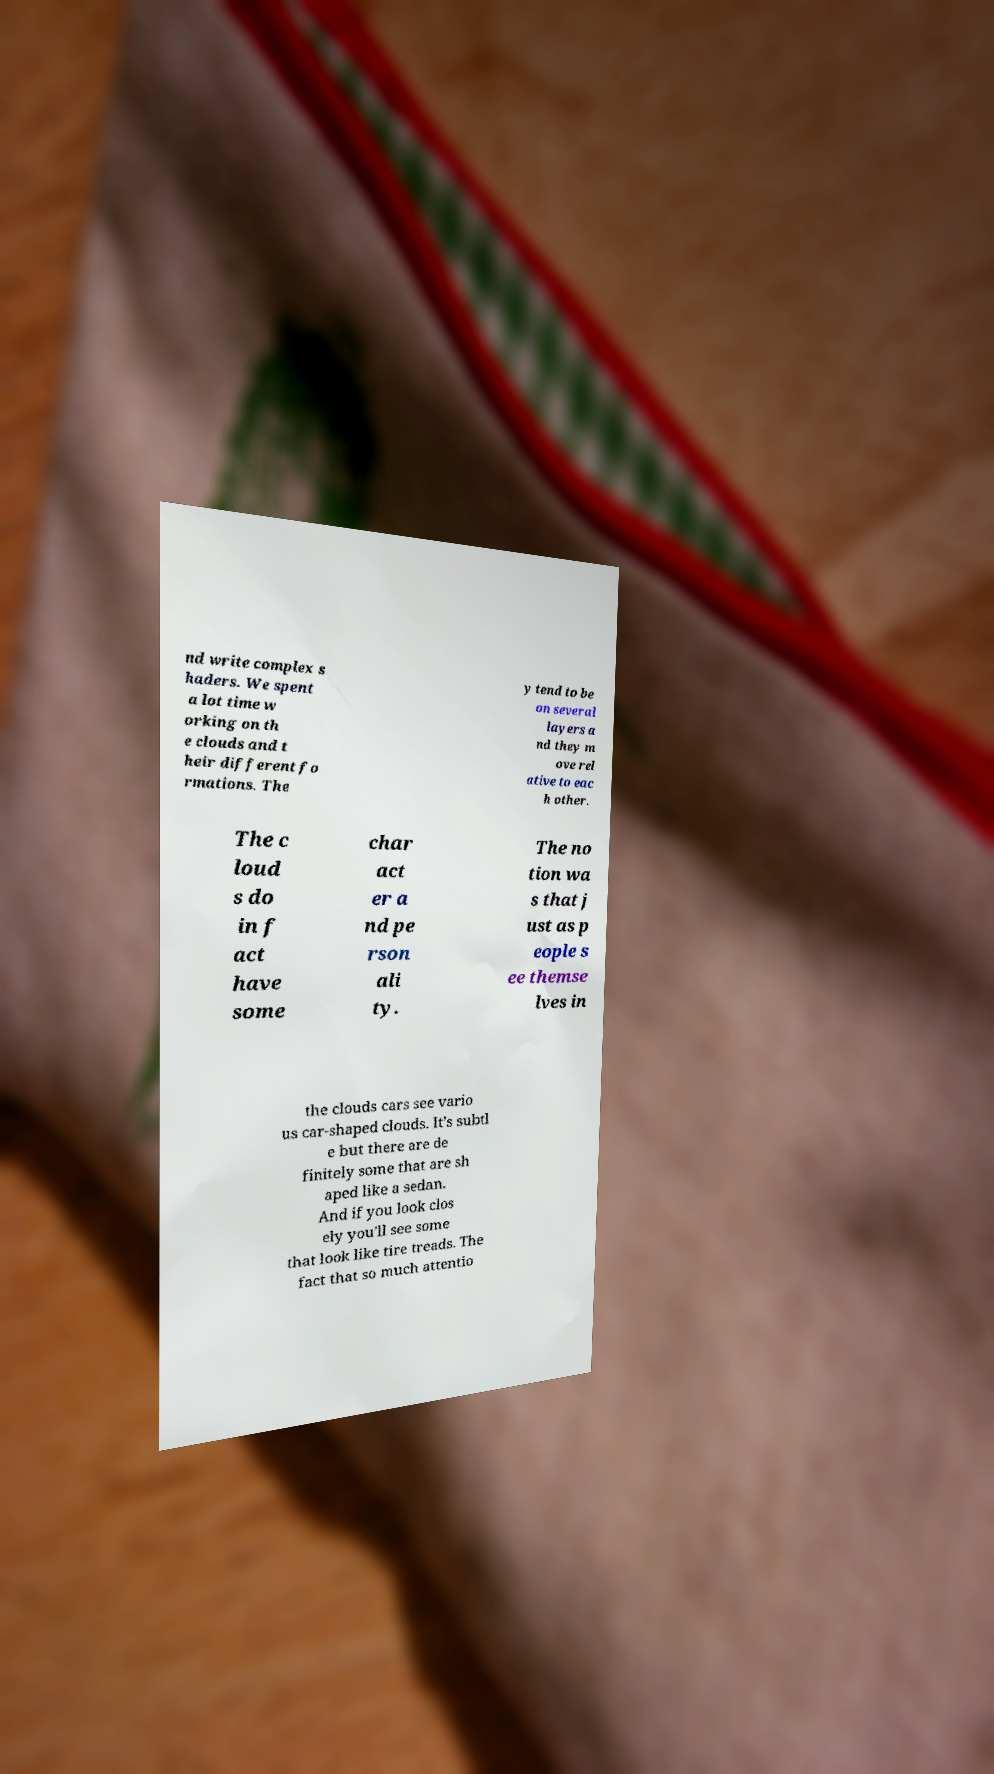Please identify and transcribe the text found in this image. nd write complex s haders. We spent a lot time w orking on th e clouds and t heir different fo rmations. The y tend to be on several layers a nd they m ove rel ative to eac h other. The c loud s do in f act have some char act er a nd pe rson ali ty. The no tion wa s that j ust as p eople s ee themse lves in the clouds cars see vario us car-shaped clouds. It’s subtl e but there are de finitely some that are sh aped like a sedan. And if you look clos ely you’ll see some that look like tire treads. The fact that so much attentio 